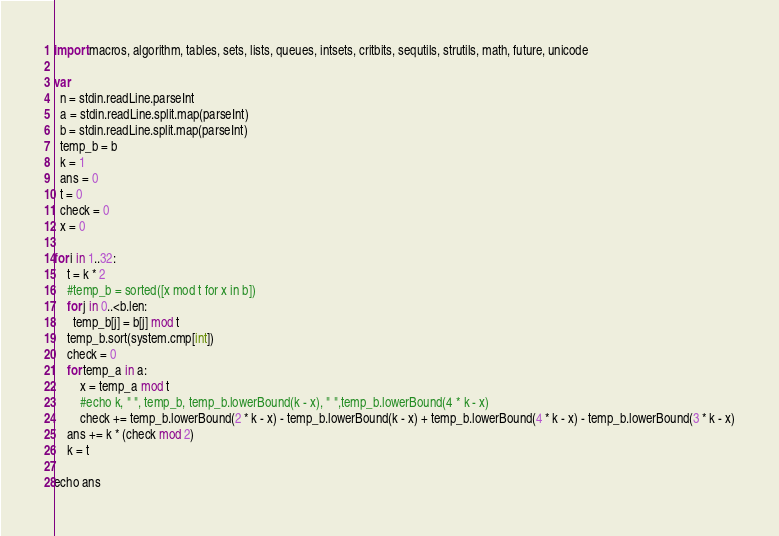<code> <loc_0><loc_0><loc_500><loc_500><_Nim_>import macros, algorithm, tables, sets, lists, queues, intsets, critbits, sequtils, strutils, math, future, unicode

var
  n = stdin.readLine.parseInt
  a = stdin.readLine.split.map(parseInt)
  b = stdin.readLine.split.map(parseInt)
  temp_b = b
  k = 1
  ans = 0
  t = 0
  check = 0
  x = 0

for i in 1..32:
    t = k * 2
    #temp_b = sorted([x mod t for x in b])
    for j in 0..<b.len:
      temp_b[j] = b[j] mod t
    temp_b.sort(system.cmp[int])
    check = 0
    for temp_a in a:
        x = temp_a mod t
        #echo k, " ", temp_b, temp_b.lowerBound(k - x), " ",temp_b.lowerBound(4 * k - x)
        check += temp_b.lowerBound(2 * k - x) - temp_b.lowerBound(k - x) + temp_b.lowerBound(4 * k - x) - temp_b.lowerBound(3 * k - x)
    ans += k * (check mod 2)
    k = t

echo ans
</code> 